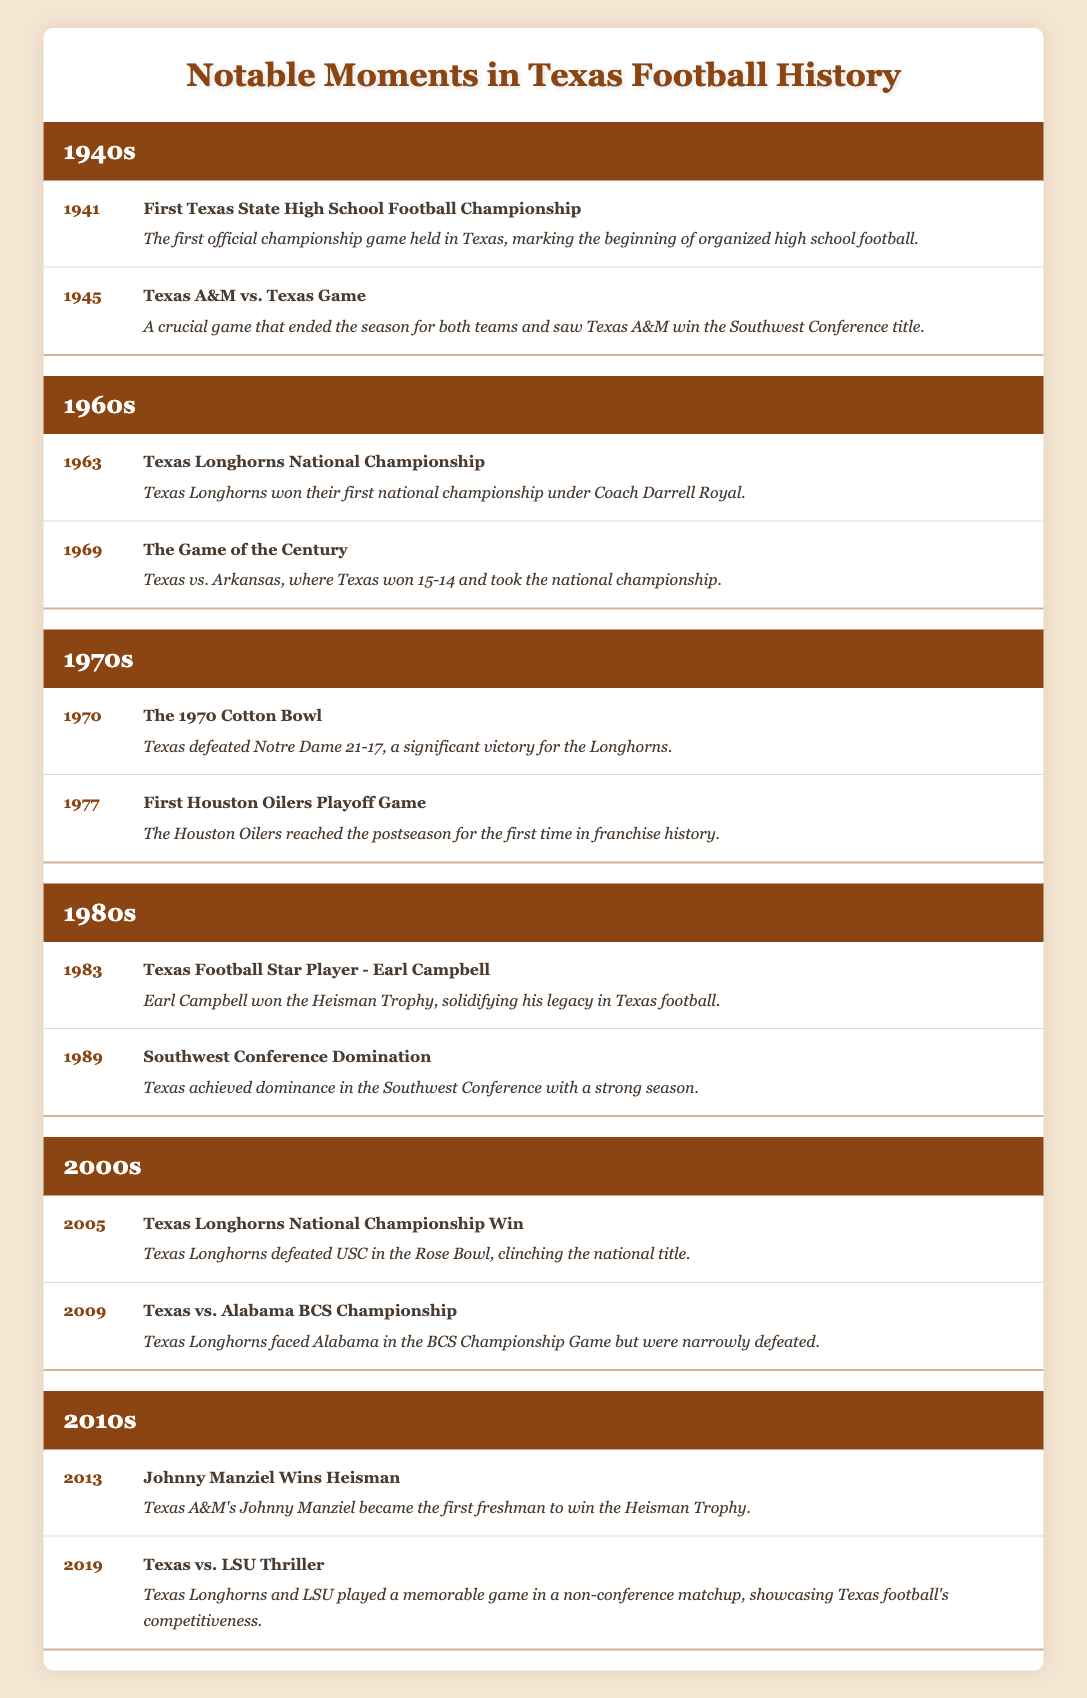What significant event occurred in Texas football in 1963? The table shows that in 1963, the Texas Longhorns won their first national championship under Coach Darrell Royal.
Answer: Texas Longhorns National Championship Which decade saw Earl Campbell win the Heisman Trophy? According to the table, Earl Campbell won the Heisman Trophy in 1983, which is part of the 1980s.
Answer: 1980s Did the Texas Longhorns win the BCS Championship Game in 2009? The table indicates that in 2009, the Texas Longhorns faced Alabama in the BCS Championship Game but were narrowly defeated. Therefore, the answer is no.
Answer: No What was the total number of notable moments listed for the 1970s? The table provides two notable moments for the 1970s: the 1970 Cotton Bowl victory and the first Houston Oilers playoff game in 1977. Therefore, the count is 2.
Answer: 2 What were the two notable events in Texas football that occurred in 1945? In 1945, the table lists the crucial Texas A&M vs. Texas game, which determined the Southwest Conference title. It does not show any other event specifically for 1945, thus only one notable event exists for that year.
Answer: 1 event Which event marked the beginning of organized high school football in Texas? The table notes that the first Texas State High School Football Championship in 1941 marked the beginning of organized high school football in Texas.
Answer: First Texas State High School Football Championship In which year did the Houston Oilers reach the postseason for the first time? The table specifies that the Houston Oilers reached the postseason for the first time in franchise history in 1977.
Answer: 1977 How many notable moments in the 2000s involved the Texas Longhorns winning national championships? The table shows that in 2005, the Texas Longhorns won a national championship, but does not indicate any other moment within the 2000s involving national championship wins. Thus, there is 1 significant moment.
Answer: 1 moment 